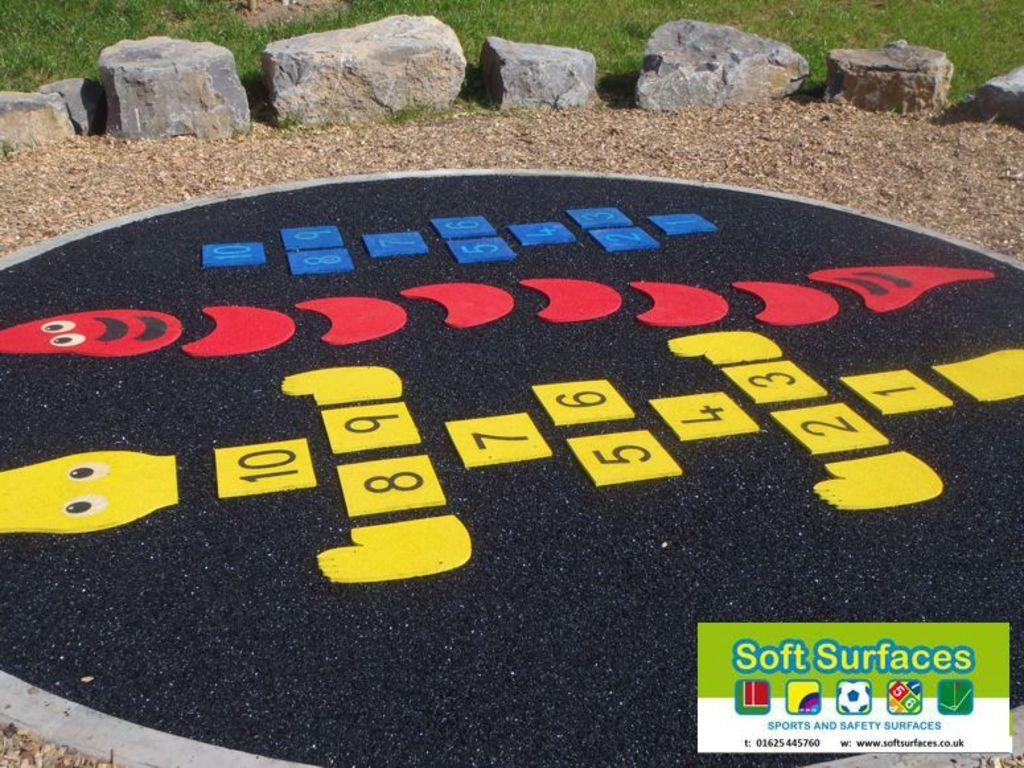What can be seen on the surface in the image? There are numbers and symbols on the surface in the image. What type of natural environment is visible in the background of the image? There is grass and stones visible in the background of the image. Where is the sticker located in the image? The sticker is in the bottom right corner of the image. What type of surprise can be seen in the image? There is no surprise visible in the image; it features numbers and symbols on a surface. 